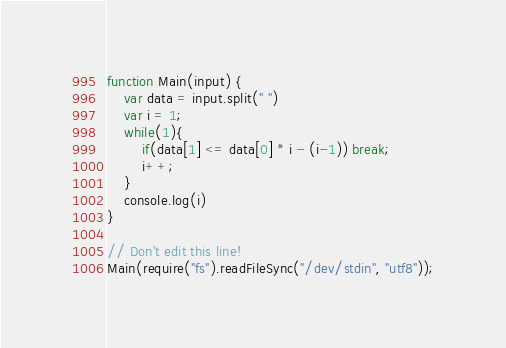Convert code to text. <code><loc_0><loc_0><loc_500><loc_500><_JavaScript_>function Main(input) {
	var data = input.split(" ")
	var i = 1;
	while(1){
		if(data[1] <= data[0] * i - (i-1)) break;
		i++;
	}
	console.log(i)
}
 
// Don't edit this line!
Main(require("fs").readFileSync("/dev/stdin", "utf8"));</code> 